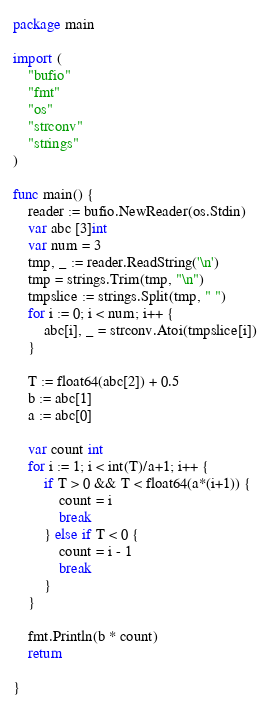Convert code to text. <code><loc_0><loc_0><loc_500><loc_500><_Go_>package main

import (
	"bufio"
	"fmt"
	"os"
	"strconv"
	"strings"
)

func main() {
	reader := bufio.NewReader(os.Stdin)
	var abc [3]int
	var num = 3
	tmp, _ := reader.ReadString('\n')
	tmp = strings.Trim(tmp, "\n")
	tmpslice := strings.Split(tmp, " ")
	for i := 0; i < num; i++ {
		abc[i], _ = strconv.Atoi(tmpslice[i])
	}

	T := float64(abc[2]) + 0.5
	b := abc[1]
	a := abc[0]

	var count int
	for i := 1; i < int(T)/a+1; i++ {
		if T > 0 && T < float64(a*(i+1)) {
			count = i
			break
		} else if T < 0 {
			count = i - 1
			break
		}
	}

	fmt.Println(b * count)
	return

}
</code> 